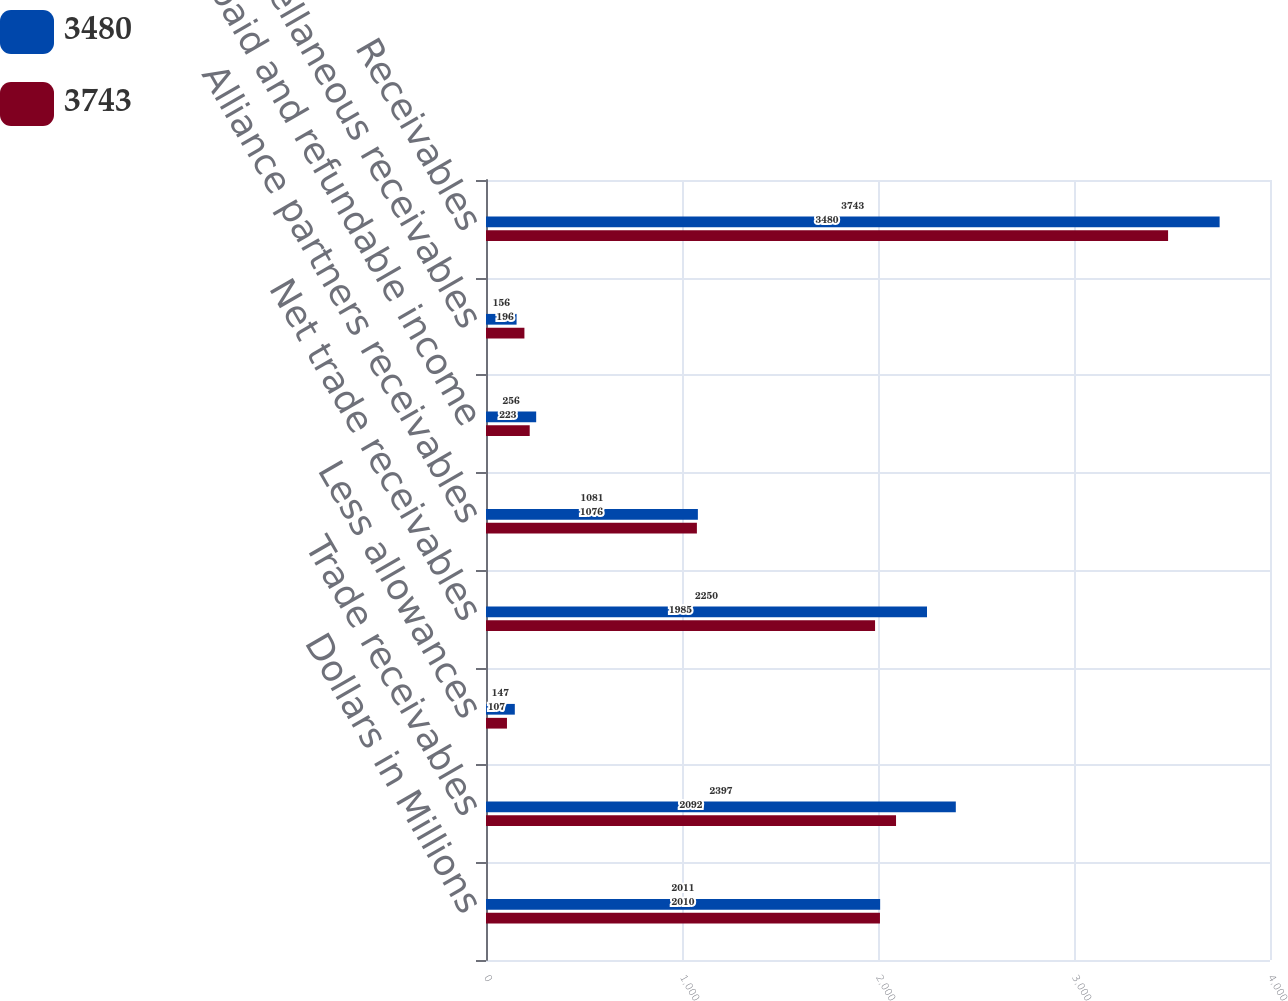Convert chart. <chart><loc_0><loc_0><loc_500><loc_500><stacked_bar_chart><ecel><fcel>Dollars in Millions<fcel>Trade receivables<fcel>Less allowances<fcel>Net trade receivables<fcel>Alliance partners receivables<fcel>Prepaid and refundable income<fcel>Miscellaneous receivables<fcel>Receivables<nl><fcel>3480<fcel>2011<fcel>2397<fcel>147<fcel>2250<fcel>1081<fcel>256<fcel>156<fcel>3743<nl><fcel>3743<fcel>2010<fcel>2092<fcel>107<fcel>1985<fcel>1076<fcel>223<fcel>196<fcel>3480<nl></chart> 